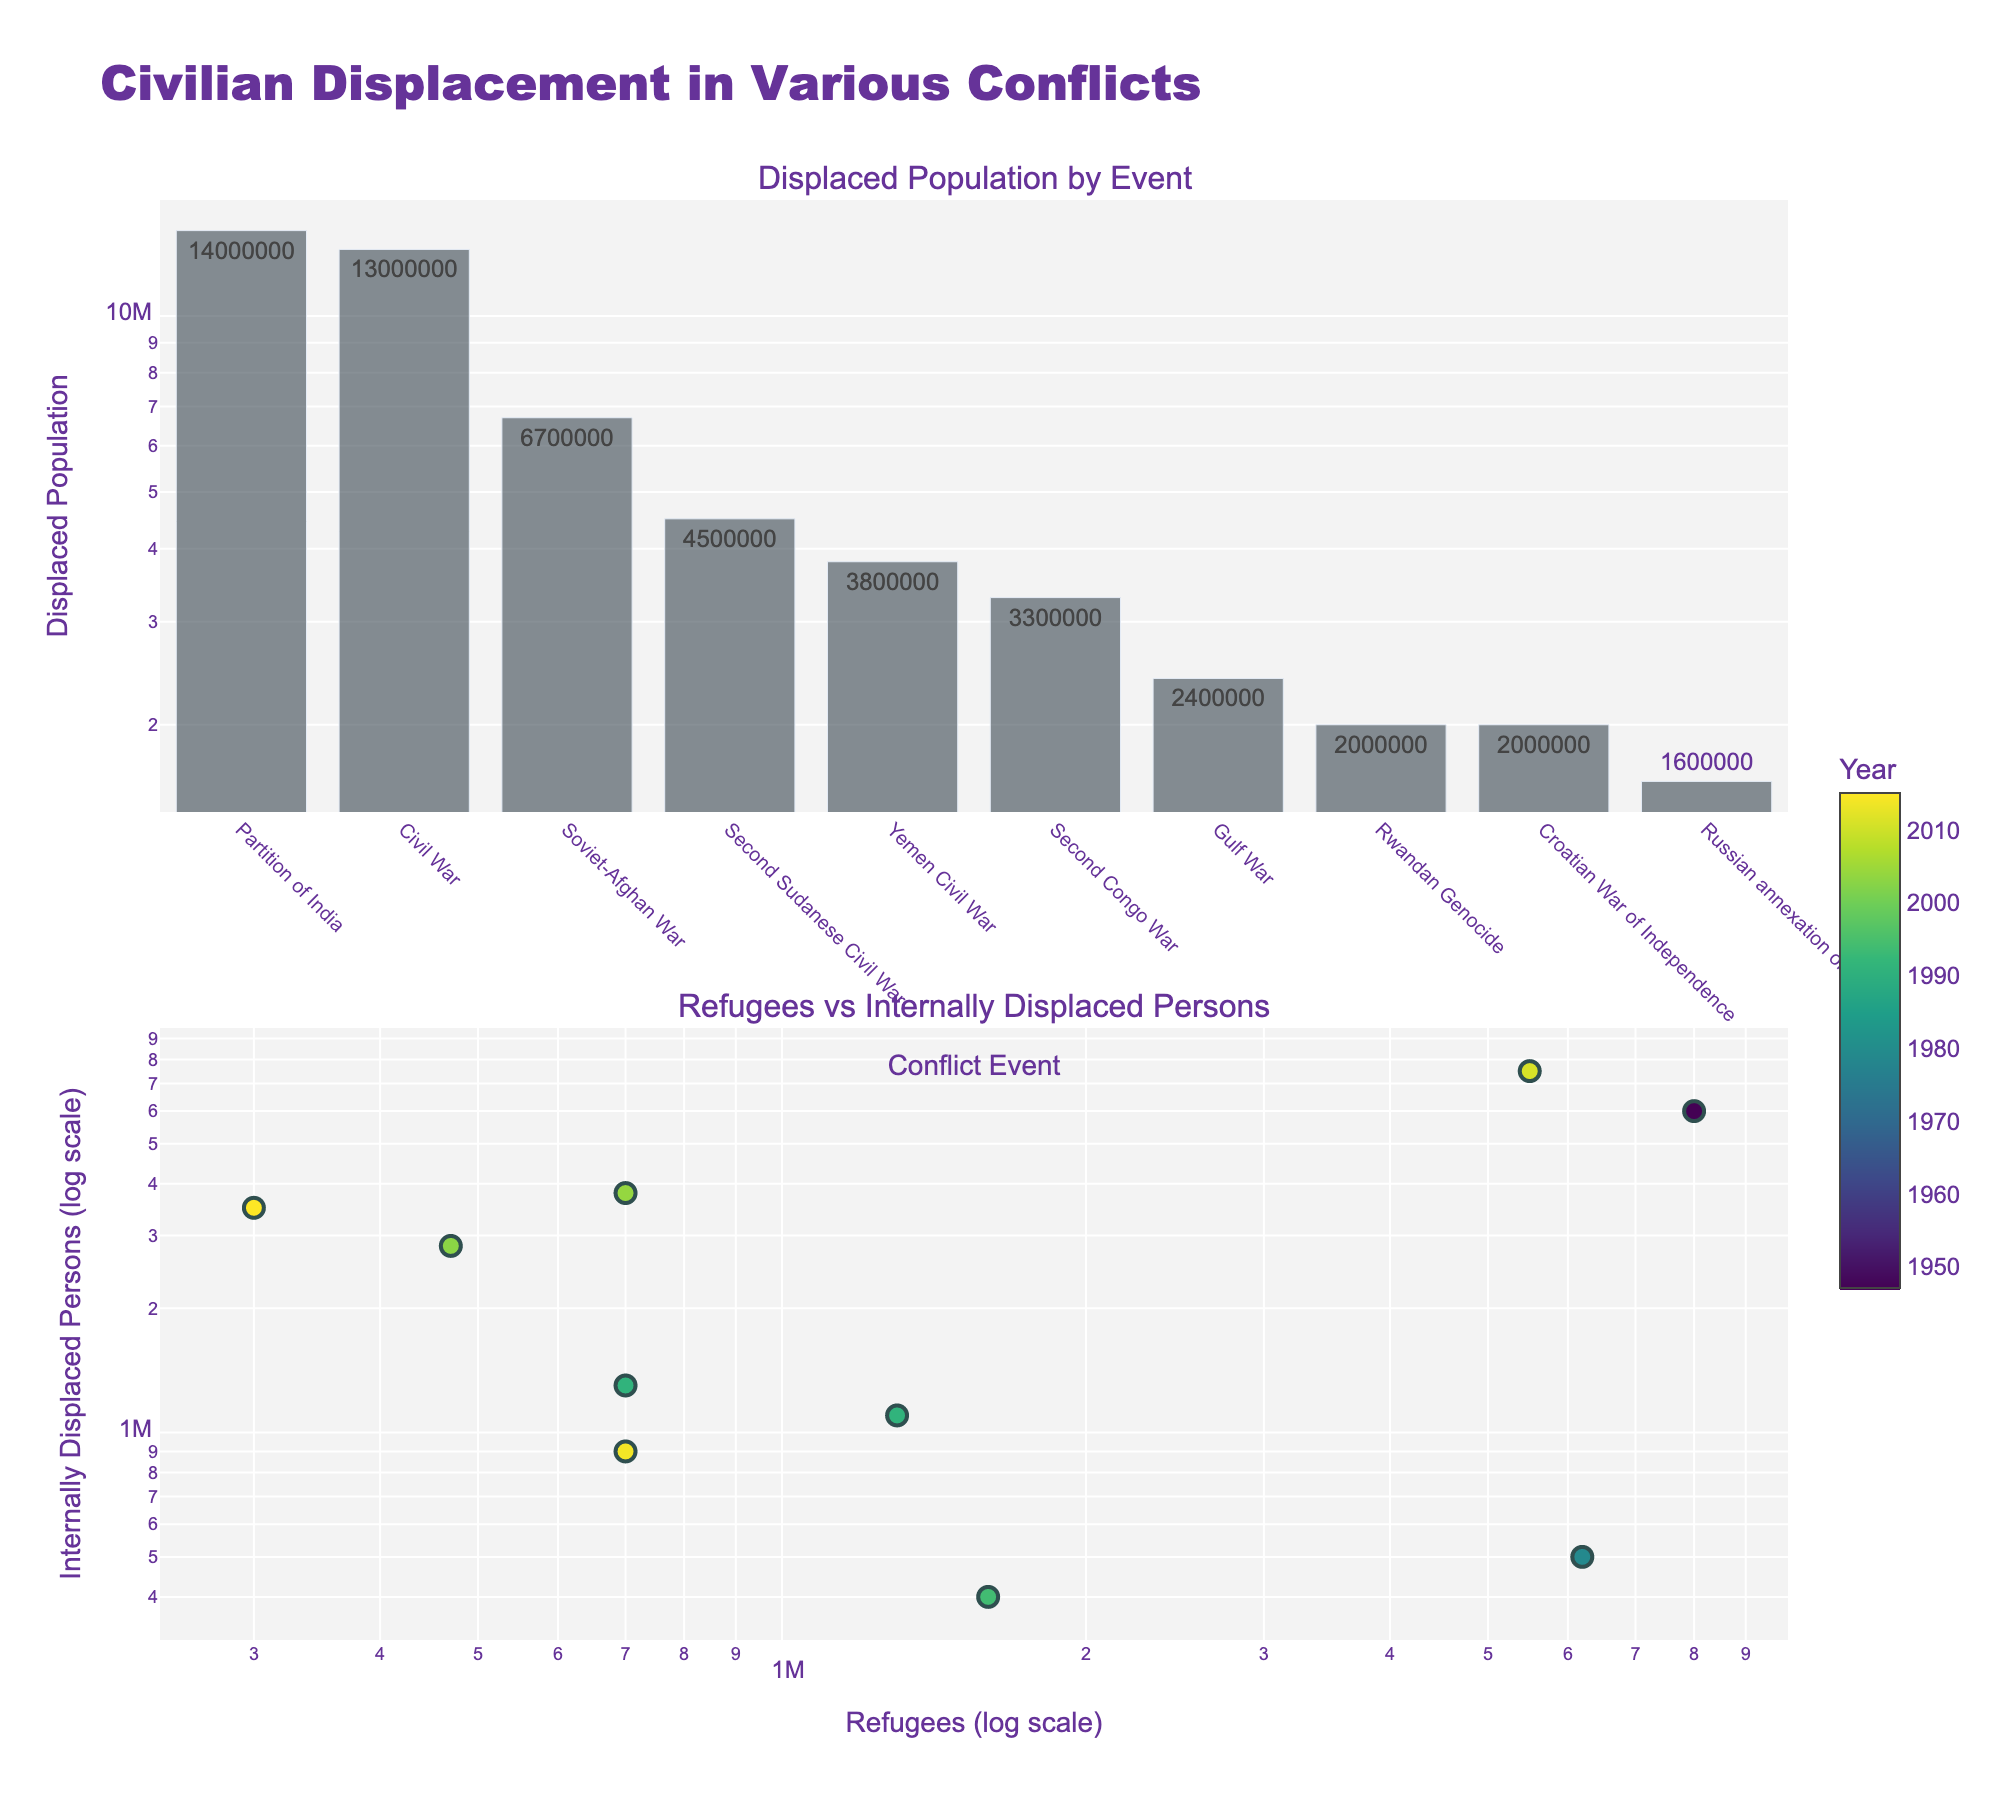What's the title of the figure? The title is displayed at the top of the figure, indicating the subject of the plot. It's written as "Civilian Displacement in Various Conflicts".
Answer: Civilian Displacement in Various Conflicts Which conflict event has the highest displaced population? The first subplot shows a bar chart where the length of each bar represents the displaced population. The highest bar corresponds to the Partition of India.
Answer: Partition of India How many conflicts have more than 5 million displaced people? By counting the bars in the first subplot that exceed the 5 million mark, there are three conflicts: Partition of India, Syrian Civil War, and Soviet-Afghan War.
Answer: Three conflicts What's the smallest value on the Internally Displaced Persons axis in log scale? In the second subplot, the y-axis for Internally Displaced Persons is clearly marked. The smallest value on this log-scaled axis is around 10,000.
Answer: 10,000 Which event has the highest number of Internally Displaced Persons? By checking the highest point on the scatter plot on the Internally Displaced Persons axis (y-axis), the Syrian Civil War has the highest number, with around 7,500,000 IDPs.
Answer: Syrian Civil War Compare the number of refugees and internally displaced persons during the Rwandan Genocide. Which is higher? The scatter plot shows data points representing the Rwandan Genocide. By looking at the corresponding x (refugees) and y (IDPs) values, the number of refugees (1,600,000) is higher than the IDPs (400,000).
Answer: Refugees Which year is associated with the displacement during the Gulf War? In the scatter plot, hovering over the Gulf War's data point indicates its color, representing the year. By referring to the color bar, we deduce that the Gulf War happened in 1991.
Answer: 1991 How does the number of refugees compare between the Croatian War of Independence and the Yemen Civil War? Referring to the scatter plot, the Croatian War of Independence has 700,000 refugees while the Yemen Civil War has 300,000 refugees. Therefore, the Croatian War of Independence has more refugees.
Answer: Croatian War of Independence has more What's the ratio of refugees to internally displaced persons for the Second Congo War? Identifying the Second Congo War on the scatter plot, we see 470,000 refugees and 2,830,000 IDPs. The ratio is calculated as 470,000 / 2,830,000, which approximates to 0.166.
Answer: Approximately 0.17 